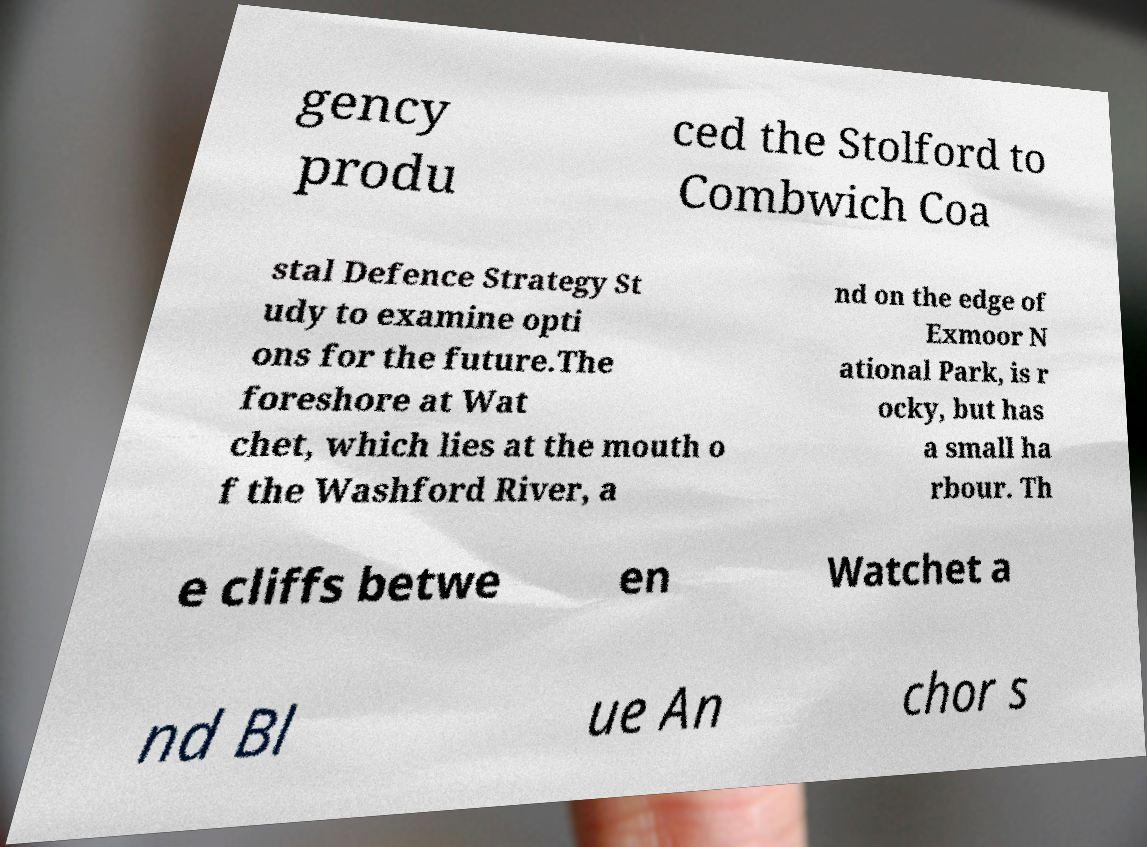I need the written content from this picture converted into text. Can you do that? gency produ ced the Stolford to Combwich Coa stal Defence Strategy St udy to examine opti ons for the future.The foreshore at Wat chet, which lies at the mouth o f the Washford River, a nd on the edge of Exmoor N ational Park, is r ocky, but has a small ha rbour. Th e cliffs betwe en Watchet a nd Bl ue An chor s 